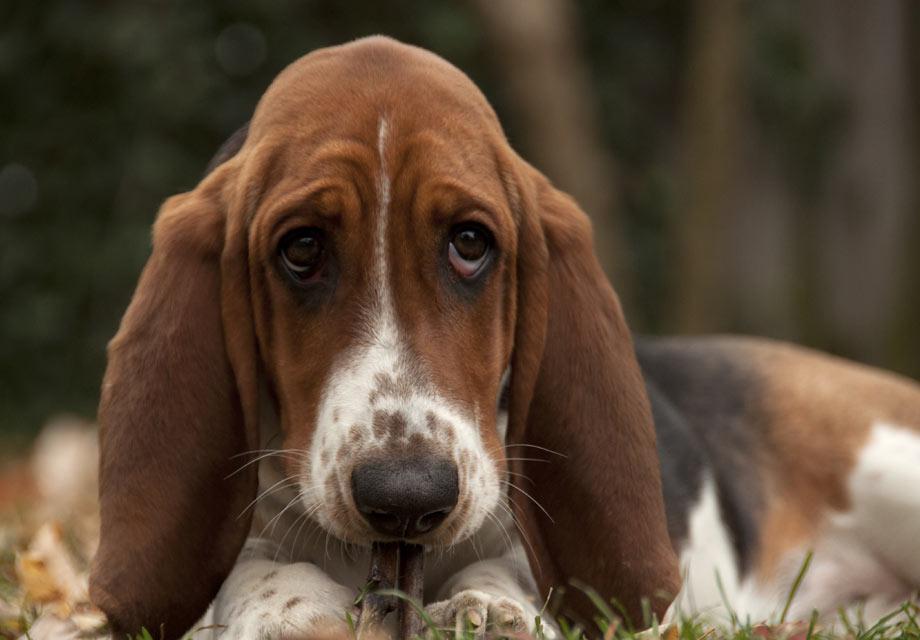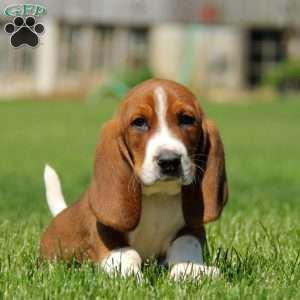The first image is the image on the left, the second image is the image on the right. For the images shown, is this caption "At least three puppies are positioned directly next to each other in one photograph." true? Answer yes or no. No. The first image is the image on the left, the second image is the image on the right. For the images displayed, is the sentence "There are 4 or more dogs, and one of them is being held up by a human." factually correct? Answer yes or no. No. 